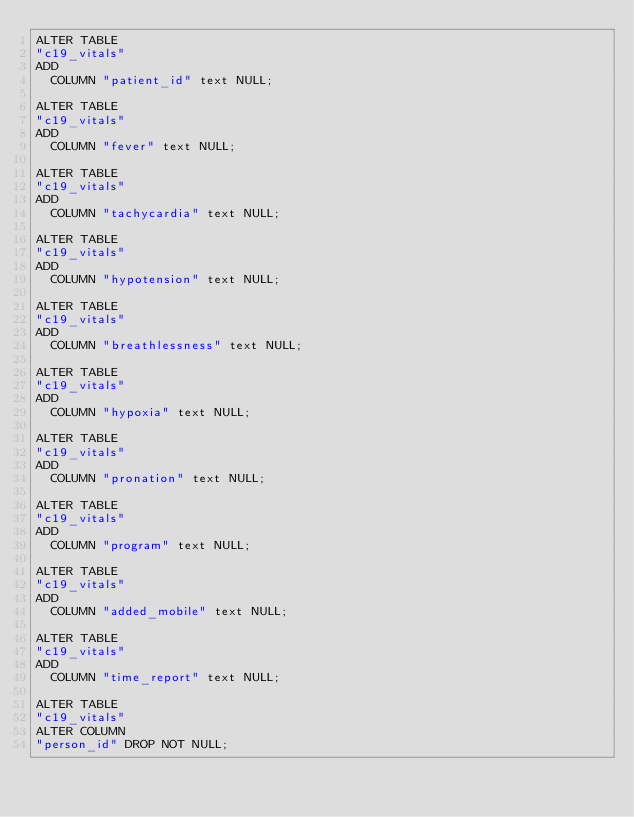Convert code to text. <code><loc_0><loc_0><loc_500><loc_500><_SQL_>ALTER TABLE
"c19_vitals"
ADD
  COLUMN "patient_id" text NULL;

ALTER TABLE
"c19_vitals"
ADD
  COLUMN "fever" text NULL;

ALTER TABLE
"c19_vitals"
ADD
  COLUMN "tachycardia" text NULL;

ALTER TABLE
"c19_vitals"
ADD
  COLUMN "hypotension" text NULL;

ALTER TABLE
"c19_vitals"
ADD
  COLUMN "breathlessness" text NULL;

ALTER TABLE
"c19_vitals"
ADD
  COLUMN "hypoxia" text NULL;

ALTER TABLE
"c19_vitals"
ADD
  COLUMN "pronation" text NULL;

ALTER TABLE
"c19_vitals"
ADD
  COLUMN "program" text NULL;

ALTER TABLE
"c19_vitals"
ADD
  COLUMN "added_mobile" text NULL;

ALTER TABLE
"c19_vitals"
ADD
  COLUMN "time_report" text NULL;

ALTER TABLE
"c19_vitals"
ALTER COLUMN
"person_id" DROP NOT NULL;</code> 